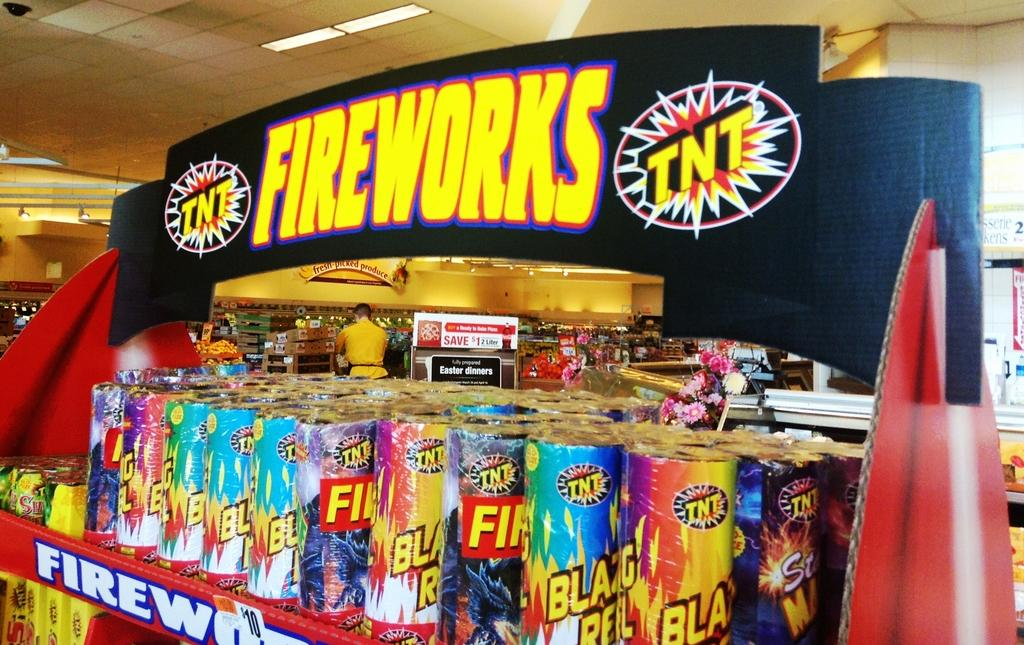<image>
Summarize the visual content of the image. A TNT fireworks sign over a display of fireworks 